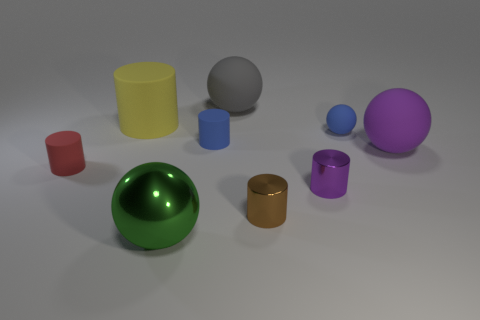Subtract all purple cylinders. How many cylinders are left? 4 Subtract all red cylinders. How many cylinders are left? 4 Subtract 1 cylinders. How many cylinders are left? 4 Subtract all gray cylinders. Subtract all purple spheres. How many cylinders are left? 5 Add 1 small brown cylinders. How many objects exist? 10 Subtract all cylinders. How many objects are left? 4 Subtract all red cylinders. Subtract all large rubber objects. How many objects are left? 5 Add 6 tiny purple things. How many tiny purple things are left? 7 Add 9 tiny red rubber objects. How many tiny red rubber objects exist? 10 Subtract 0 gray cylinders. How many objects are left? 9 